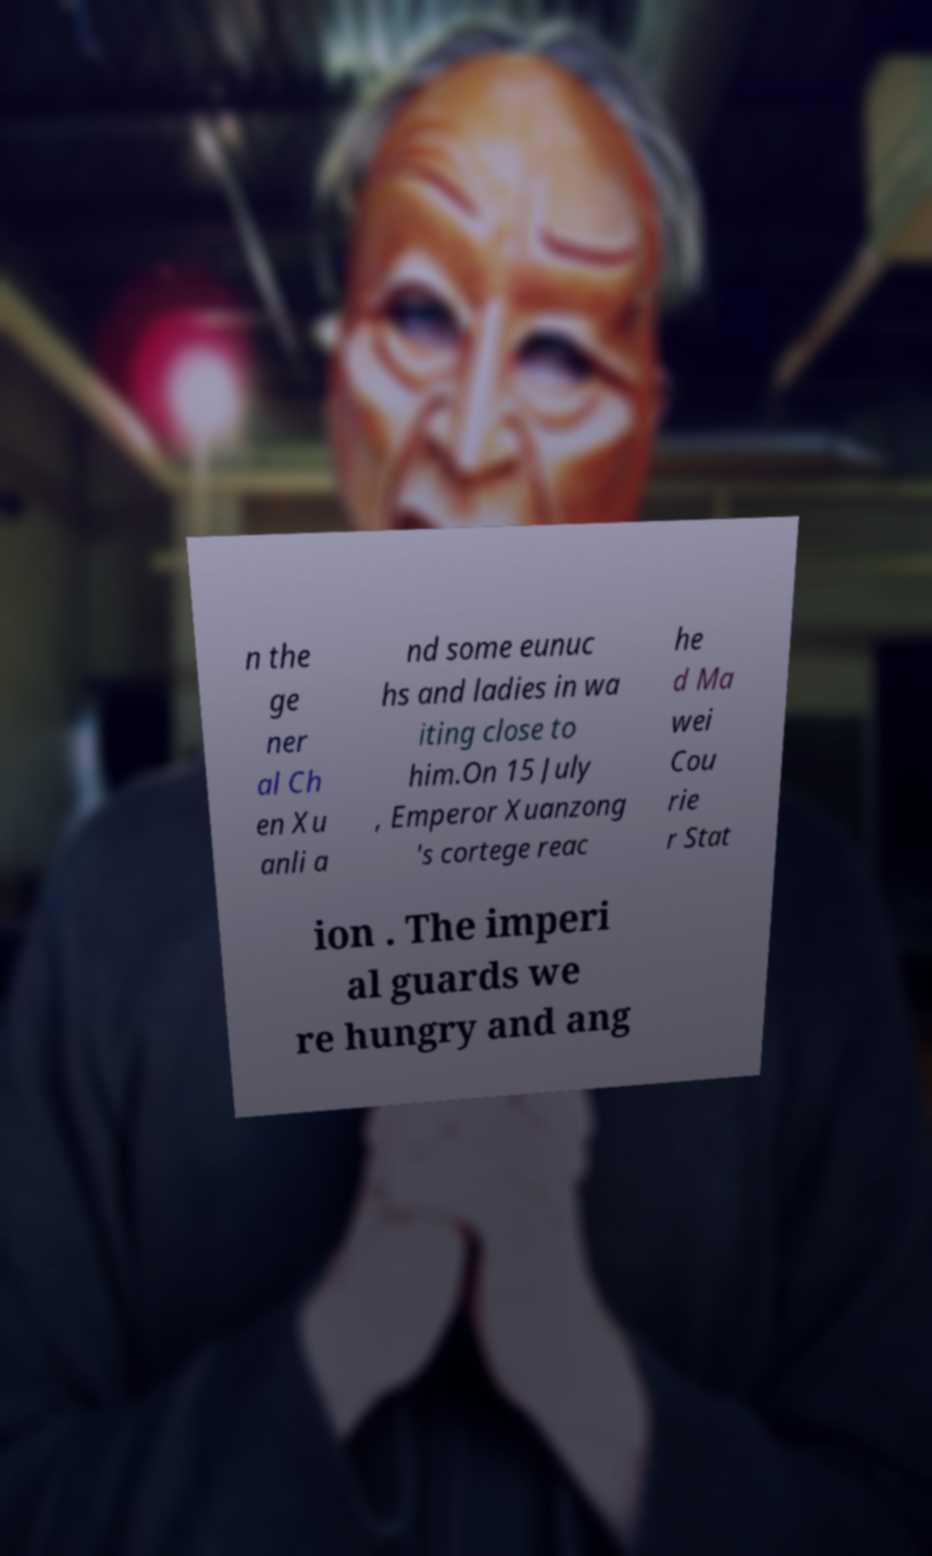Could you assist in decoding the text presented in this image and type it out clearly? n the ge ner al Ch en Xu anli a nd some eunuc hs and ladies in wa iting close to him.On 15 July , Emperor Xuanzong 's cortege reac he d Ma wei Cou rie r Stat ion . The imperi al guards we re hungry and ang 